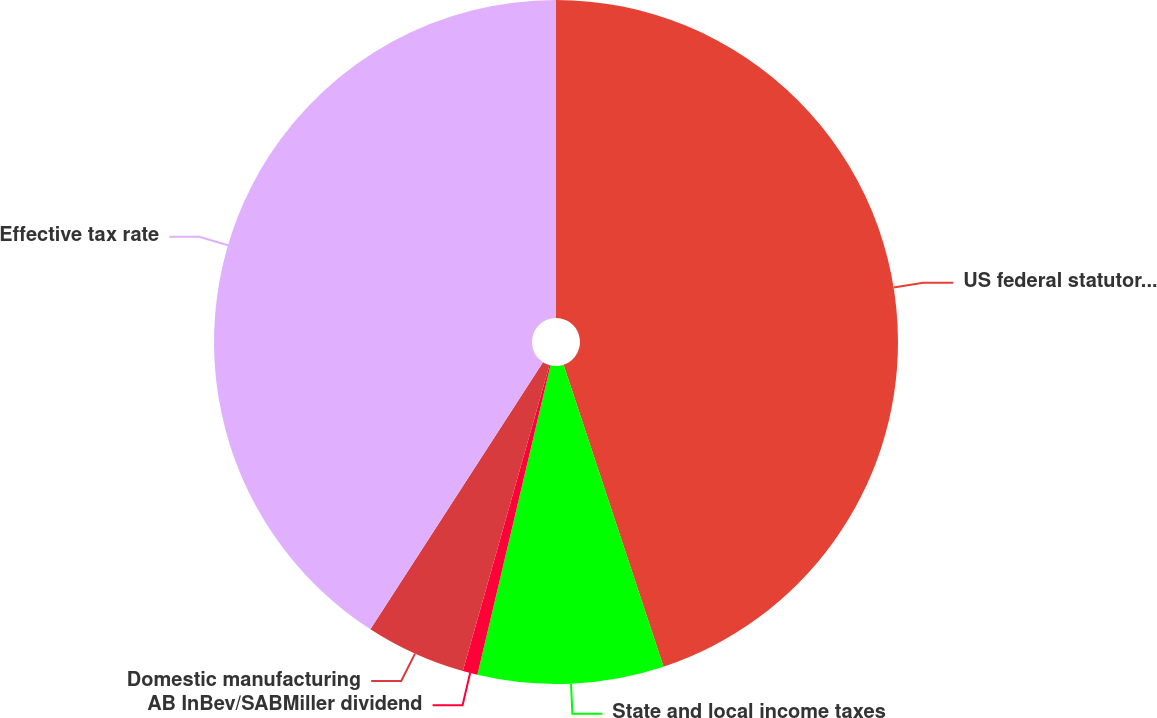Convert chart. <chart><loc_0><loc_0><loc_500><loc_500><pie_chart><fcel>US federal statutory rate<fcel>State and local income taxes<fcel>AB InBev/SABMiller dividend<fcel>Domestic manufacturing<fcel>Effective tax rate<nl><fcel>44.9%<fcel>8.78%<fcel>0.7%<fcel>4.74%<fcel>40.86%<nl></chart> 